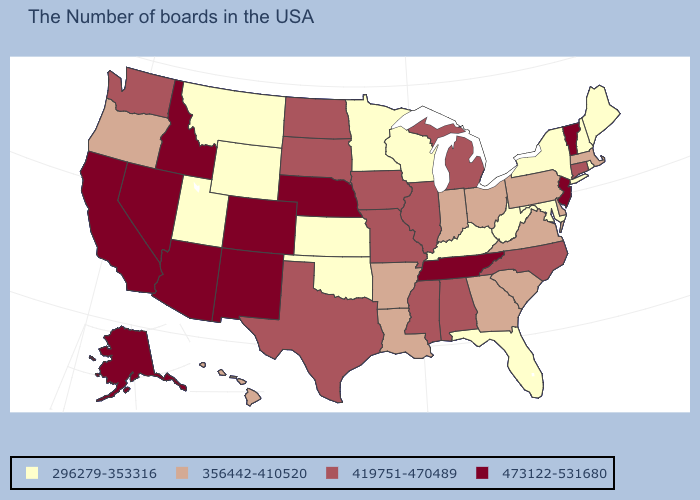Does Montana have the lowest value in the USA?
Concise answer only. Yes. Which states have the highest value in the USA?
Short answer required. Vermont, New Jersey, Tennessee, Nebraska, Colorado, New Mexico, Arizona, Idaho, Nevada, California, Alaska. What is the lowest value in the USA?
Quick response, please. 296279-353316. What is the value of Pennsylvania?
Answer briefly. 356442-410520. What is the value of Indiana?
Be succinct. 356442-410520. What is the lowest value in the South?
Keep it brief. 296279-353316. Does Minnesota have the highest value in the USA?
Keep it brief. No. Name the states that have a value in the range 296279-353316?
Concise answer only. Maine, Rhode Island, New Hampshire, New York, Maryland, West Virginia, Florida, Kentucky, Wisconsin, Minnesota, Kansas, Oklahoma, Wyoming, Utah, Montana. Name the states that have a value in the range 356442-410520?
Quick response, please. Massachusetts, Delaware, Pennsylvania, Virginia, South Carolina, Ohio, Georgia, Indiana, Louisiana, Arkansas, Oregon, Hawaii. Does Utah have the highest value in the USA?
Be succinct. No. What is the value of Maine?
Be succinct. 296279-353316. How many symbols are there in the legend?
Answer briefly. 4. What is the value of Kentucky?
Give a very brief answer. 296279-353316. What is the value of New Hampshire?
Answer briefly. 296279-353316. Does Tennessee have the highest value in the South?
Give a very brief answer. Yes. 